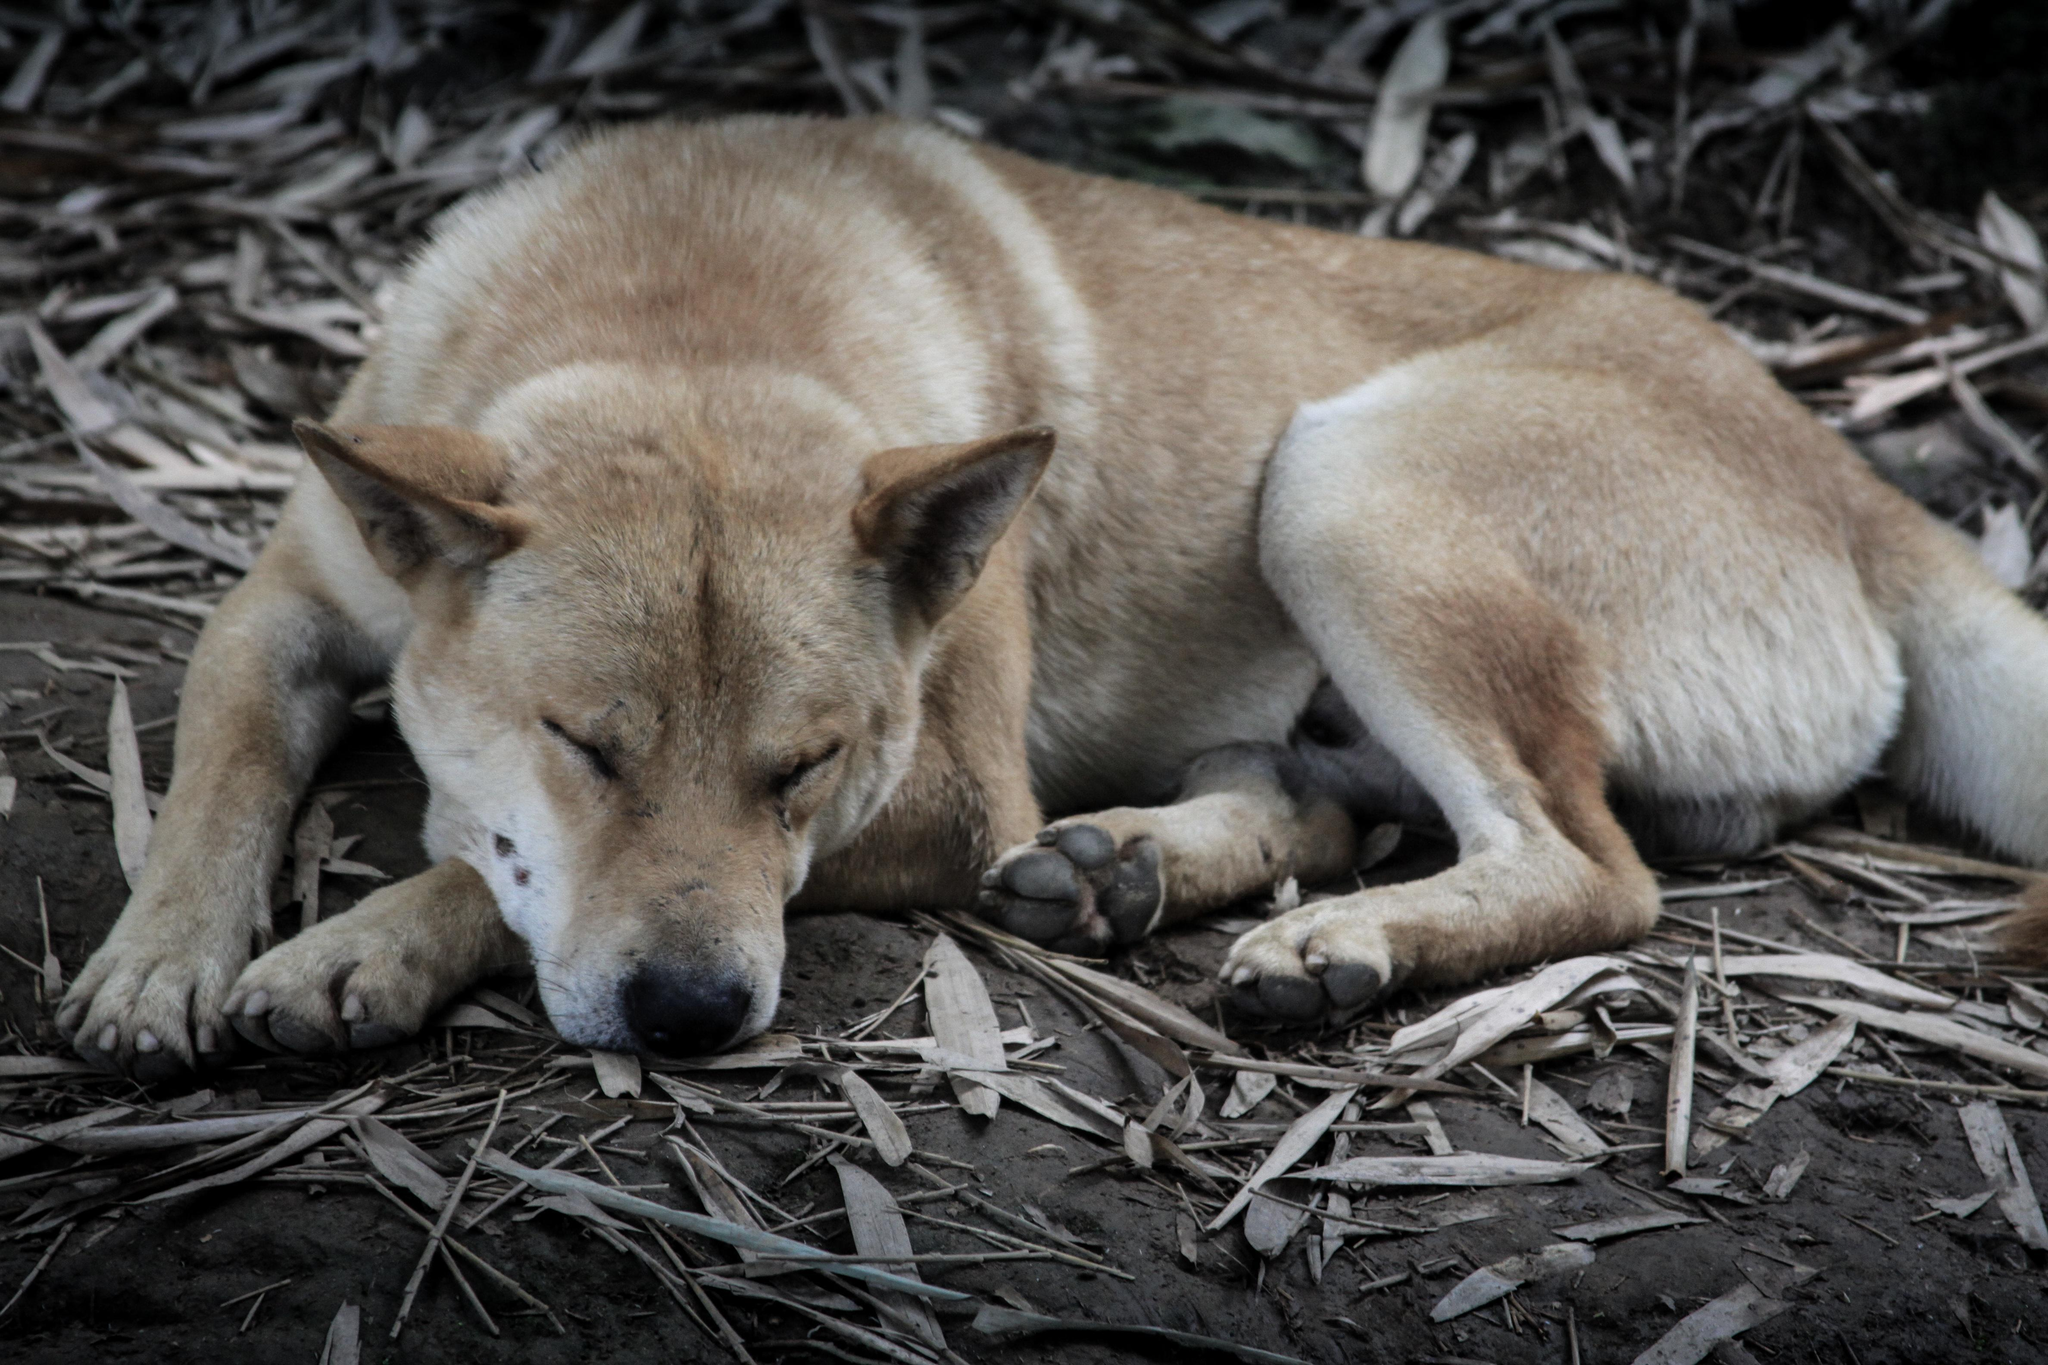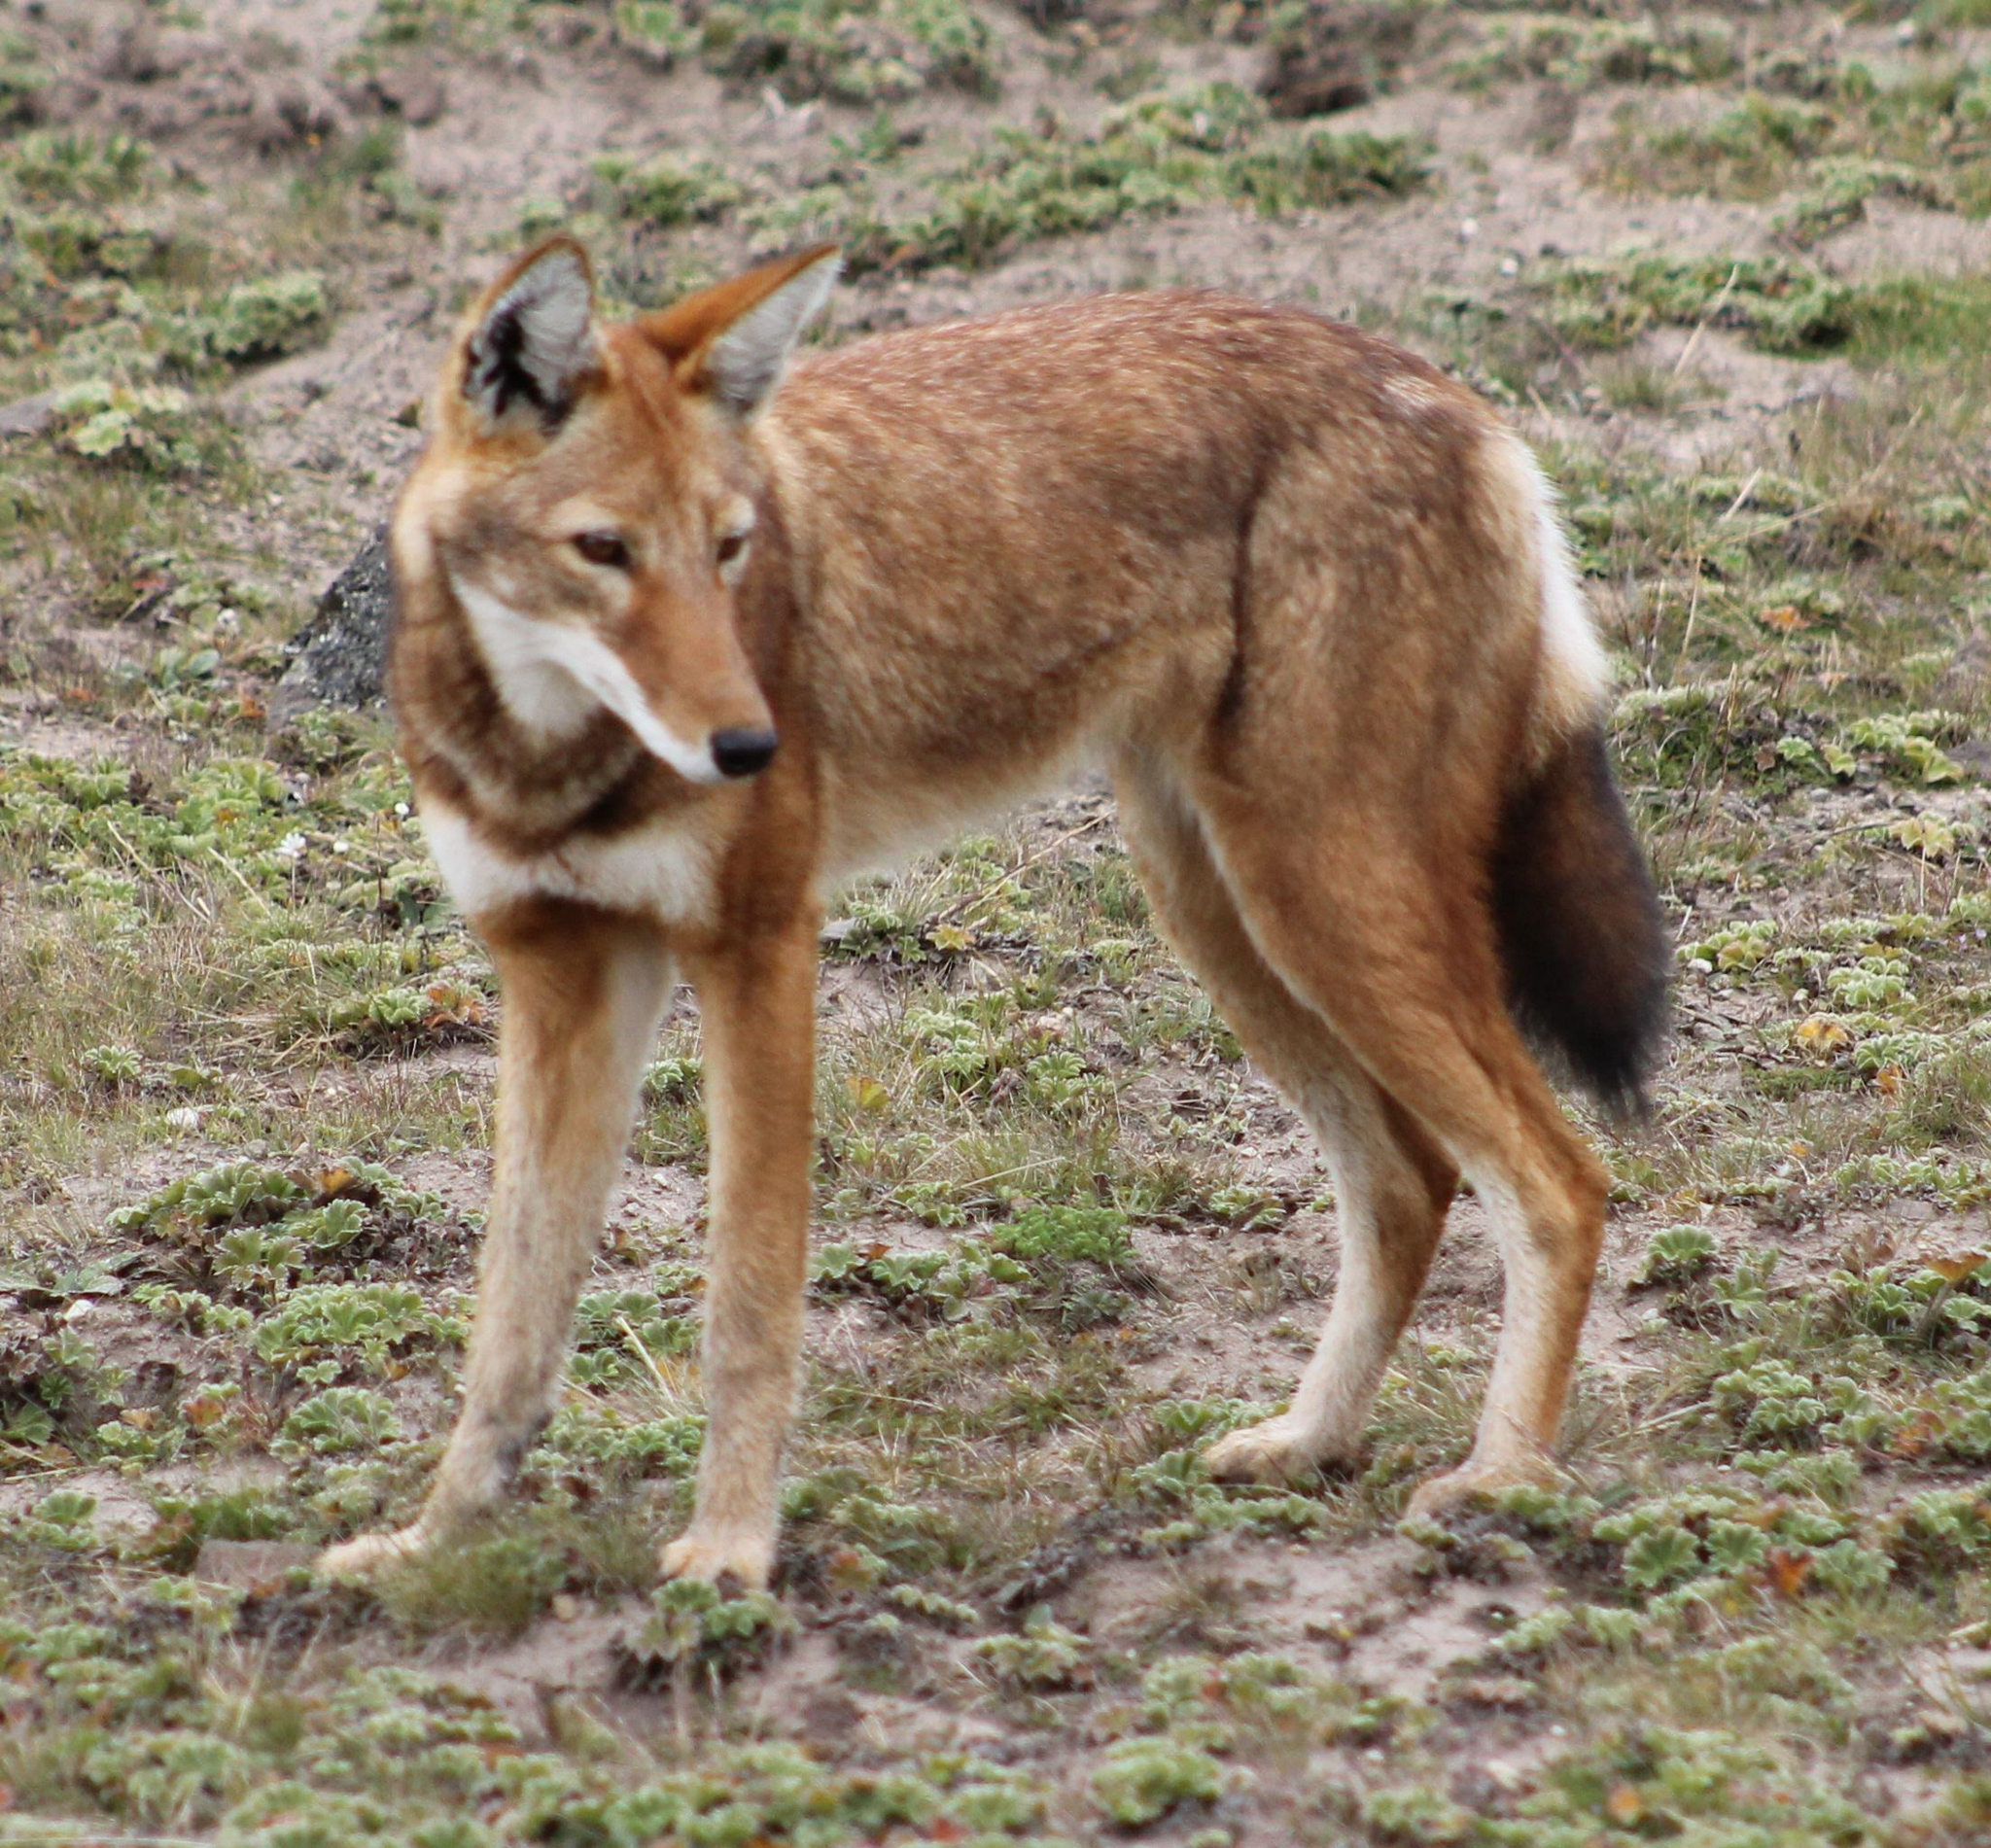The first image is the image on the left, the second image is the image on the right. For the images displayed, is the sentence "Each image contains one open-eyed dog, and the dogs in the left and right images appear to look toward each other." factually correct? Answer yes or no. No. The first image is the image on the left, the second image is the image on the right. Evaluate the accuracy of this statement regarding the images: "There are two dogs in grassy areas.". Is it true? Answer yes or no. No. 